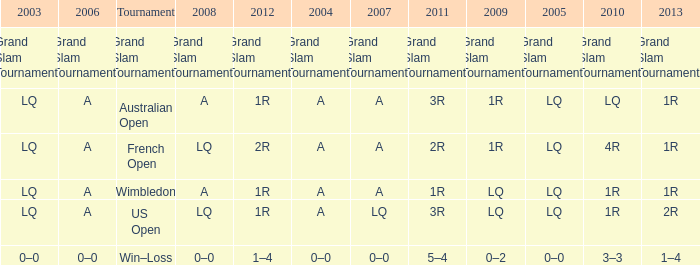Write the full table. {'header': ['2003', '2006', 'Tournament', '2008', '2012', '2004', '2007', '2011', '2009', '2005', '2010', '2013'], 'rows': [['Grand Slam Tournaments', 'Grand Slam Tournaments', 'Grand Slam Tournaments', 'Grand Slam Tournaments', 'Grand Slam Tournaments', 'Grand Slam Tournaments', 'Grand Slam Tournaments', 'Grand Slam Tournaments', 'Grand Slam Tournaments', 'Grand Slam Tournaments', 'Grand Slam Tournaments', 'Grand Slam Tournaments'], ['LQ', 'A', 'Australian Open', 'A', '1R', 'A', 'A', '3R', '1R', 'LQ', 'LQ', '1R'], ['LQ', 'A', 'French Open', 'LQ', '2R', 'A', 'A', '2R', '1R', 'LQ', '4R', '1R'], ['LQ', 'A', 'Wimbledon', 'A', '1R', 'A', 'A', '1R', 'LQ', 'LQ', '1R', '1R'], ['LQ', 'A', 'US Open', 'LQ', '1R', 'A', 'LQ', '3R', 'LQ', 'LQ', '1R', '2R'], ['0–0', '0–0', 'Win–Loss', '0–0', '1–4', '0–0', '0–0', '5–4', '0–2', '0–0', '3–3', '1–4']]} Which year has a 2003 of lq? 1R, 1R, LQ, LQ. 